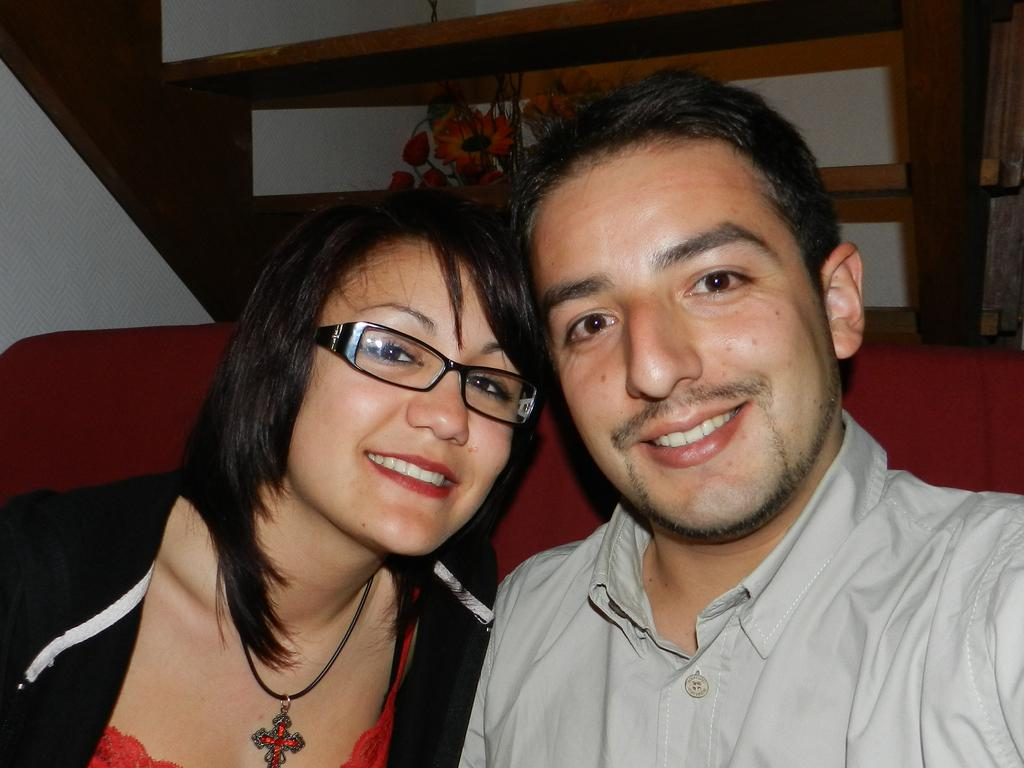How many people are in the image? There are two people in the image, a lady and a man. What are the lady and the man doing in the image? Both the lady and the man are sitting. What expressions do the lady and the man have in the image? Both the lady and the man are smiling. What can be seen in the background of the image? There is a decorative element and stairs visible in the background of the image. What type of print can be seen on the lady's shirt in the image? There is no print visible on the lady's shirt in the image. What question is the man asking the lady in the image? There is no conversation or question being asked in the image; both the lady and the man are simply sitting and smiling. 